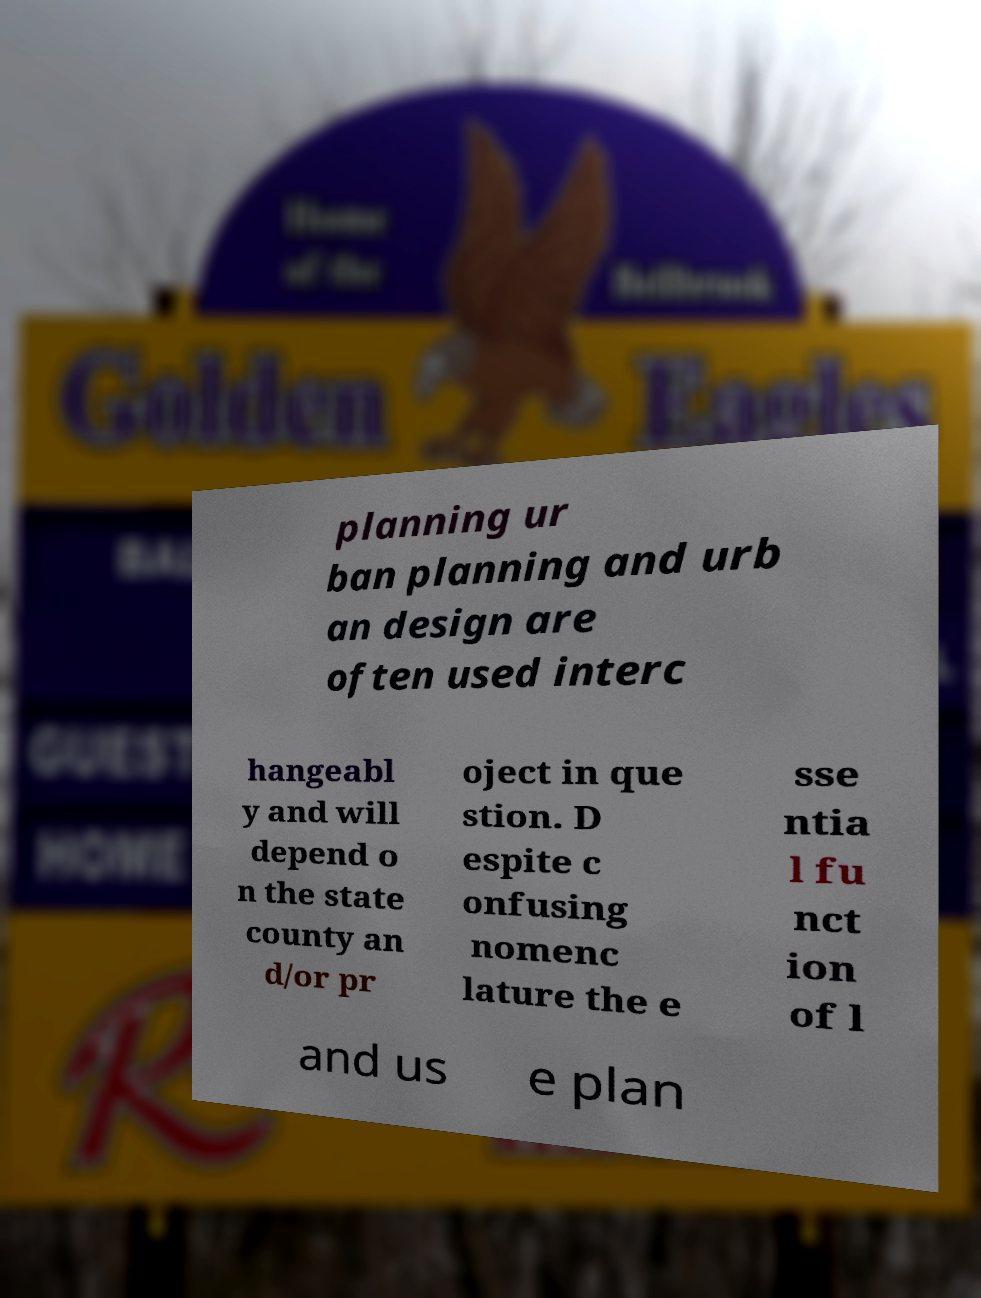Please read and relay the text visible in this image. What does it say? planning ur ban planning and urb an design are often used interc hangeabl y and will depend o n the state county an d/or pr oject in que stion. D espite c onfusing nomenc lature the e sse ntia l fu nct ion of l and us e plan 